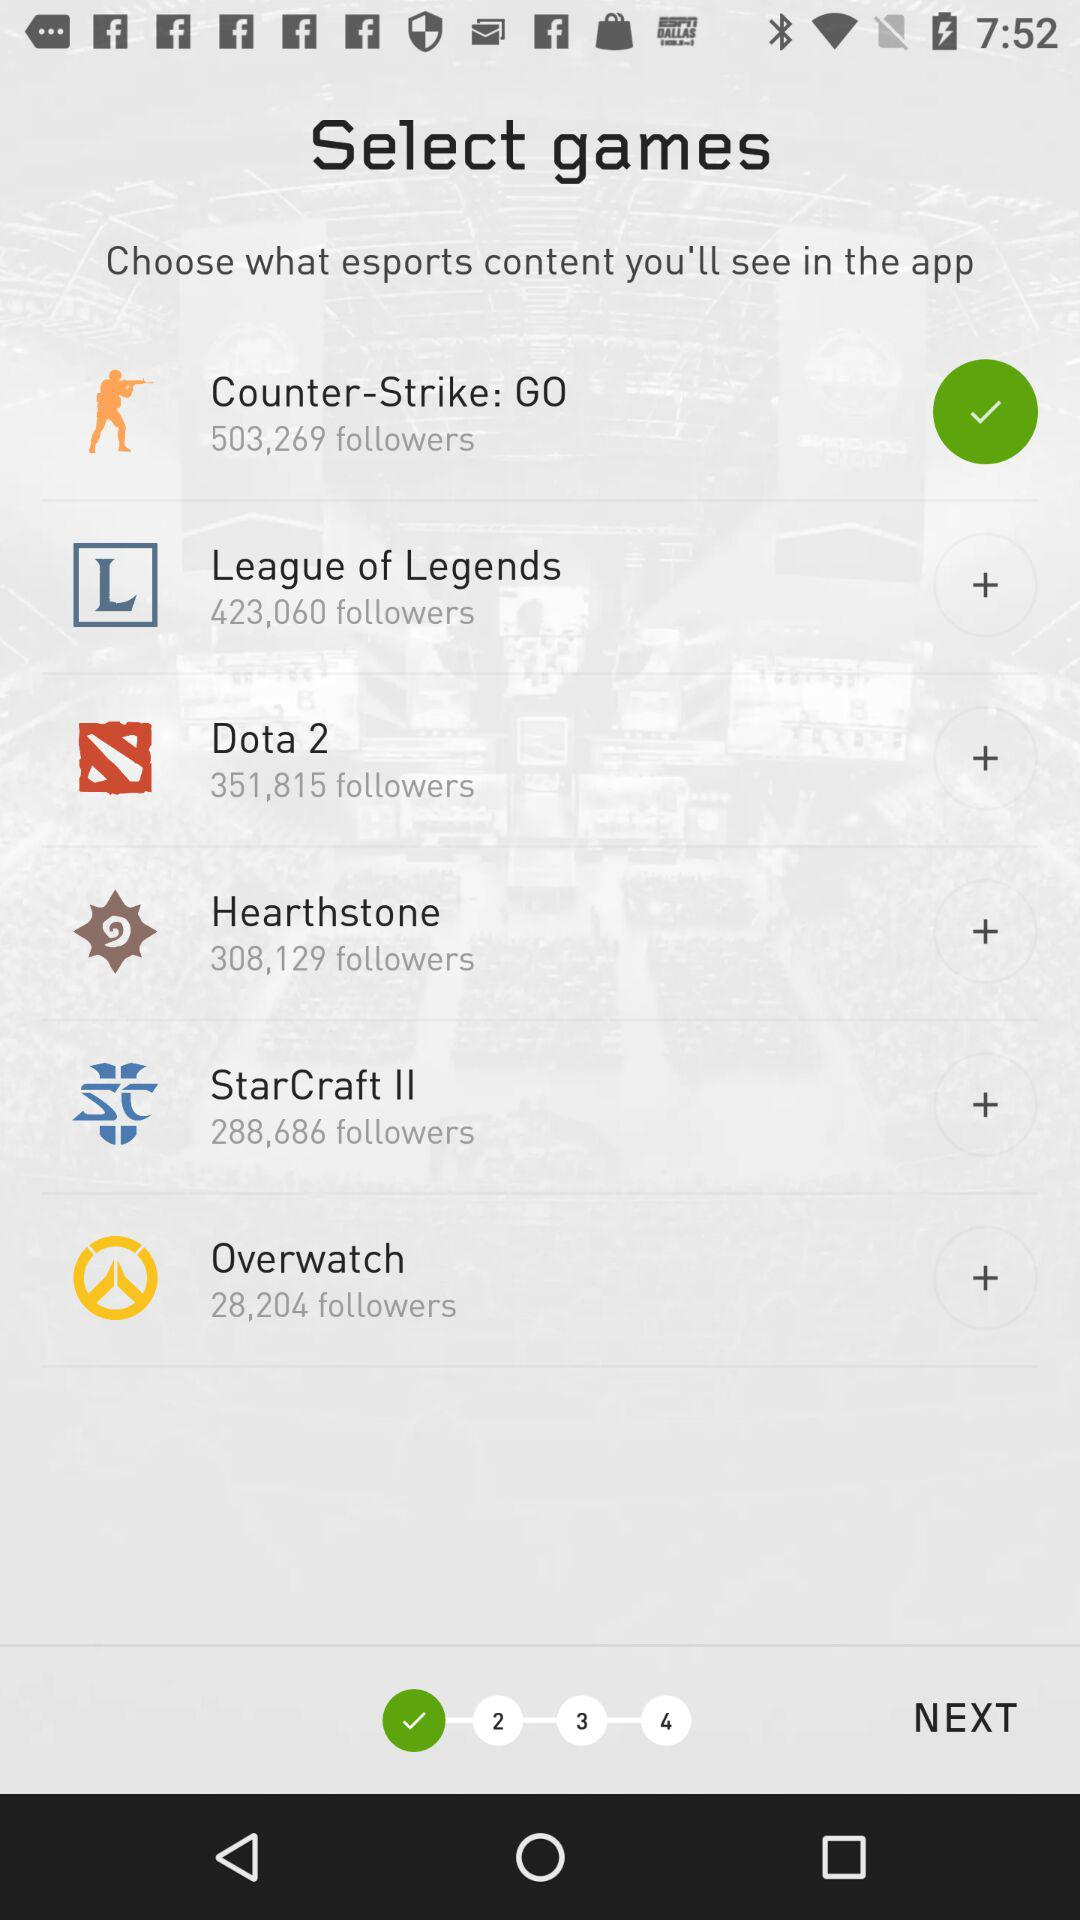How many followers does the game with the most followers have?
Answer the question using a single word or phrase. 503,269 